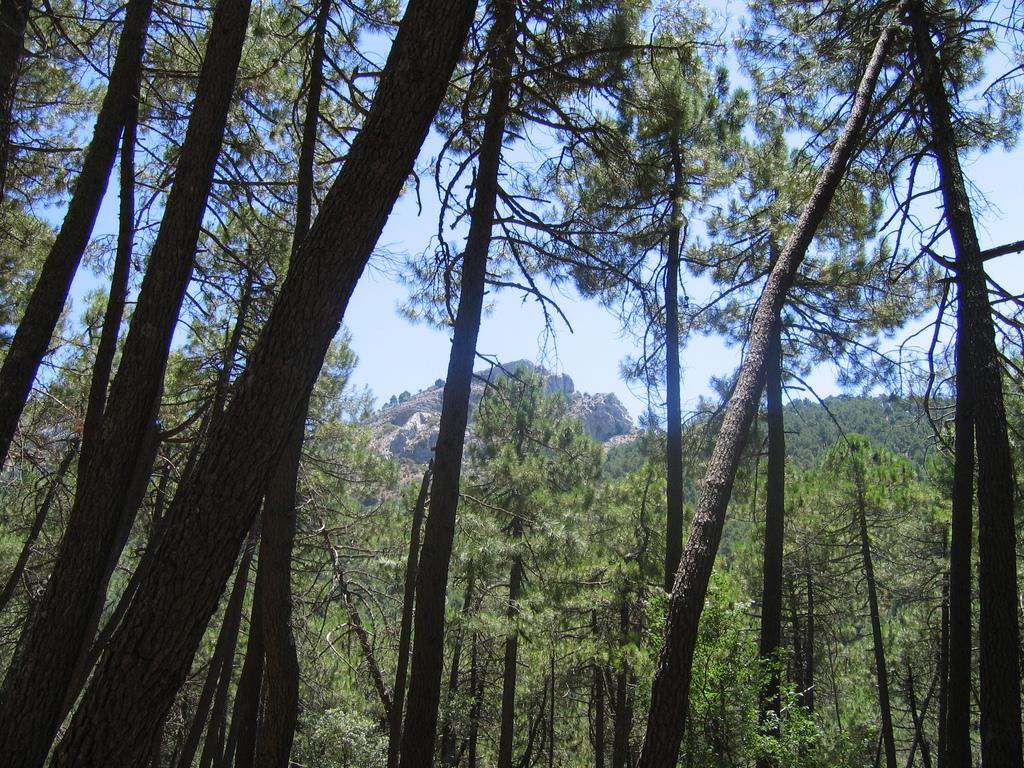What type of vegetation can be seen in the image? There are trees in the image. What type of landscape feature is present in the image? There are hills in the image. What is visible in the background of the image? The sky is visible in the image. What type of suit is the tree wearing in the image? There are no suits present in the image, as trees are not capable of wearing clothing. 